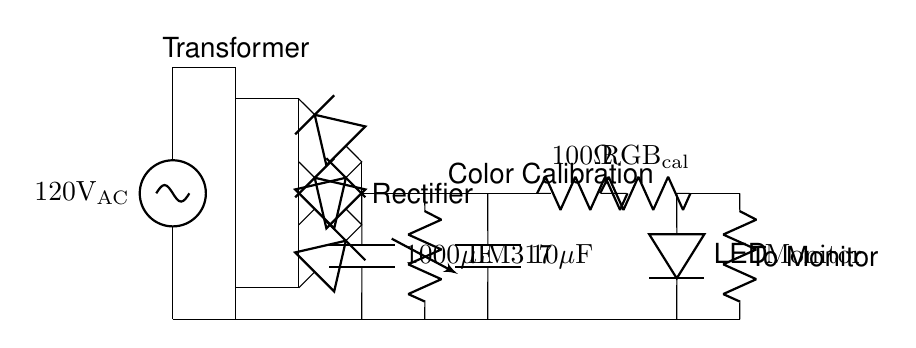What is the input voltage for this circuit? The input voltage is specified as 120 volts AC at the beginning of the diagram, indicating the source voltage that the circuit operates from.
Answer: 120 volts AC What is the function of the transformer in this circuit? The transformer is used to convert 120 volts AC to a lower AC voltage suitable for the components that follow, essential for safe operation and to meet the circuit's power requirements.
Answer: Step down voltage How many diodes are in the rectifier bridge? In total, there are four diodes shown in the rectifier bridge, arranged in a configuration that allows for the conversion of AC to DC, critical for stabilizing the voltage for the monitor.
Answer: Four What is the value of the smoothing capacitor? The smoothing capacitor is labeled as 1000 microfarads, which helps to smooth the output voltage by reducing ripple after rectification, ensuring a steady DC supply for the monitor.
Answer: 1000 microfarads What type of regulator is used in this circuit? The voltage regulator is identified as LM317, a commonly used adjustable voltage regulator that ensures the output voltage remains stable regardless of variations in input voltage or load conditions.
Answer: LM317 What does the RGB calibration circuit contain, and why is it important? The RGB calibration circuit contains a 100-ohm resistor and a RGB calibration element, which are crucial for fine-tuning the color output of the monitor, ensuring accurate color representation.
Answer: 100 ohm resistor and RGB calibration What is connected to the output of this power supply circuit? The output is connected to a load indicated as "Monitor," meaning that the power supply circuit is designed to specifically cater to the requirements of a high-end graphic design monitor.
Answer: Monitor 